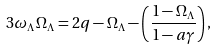<formula> <loc_0><loc_0><loc_500><loc_500>3 \omega _ { \Lambda } \Omega _ { \Lambda } = 2 q - \Omega _ { \Lambda } - \left ( \frac { 1 - \Omega _ { \Lambda } } { 1 - a \gamma } \right ) ,</formula> 